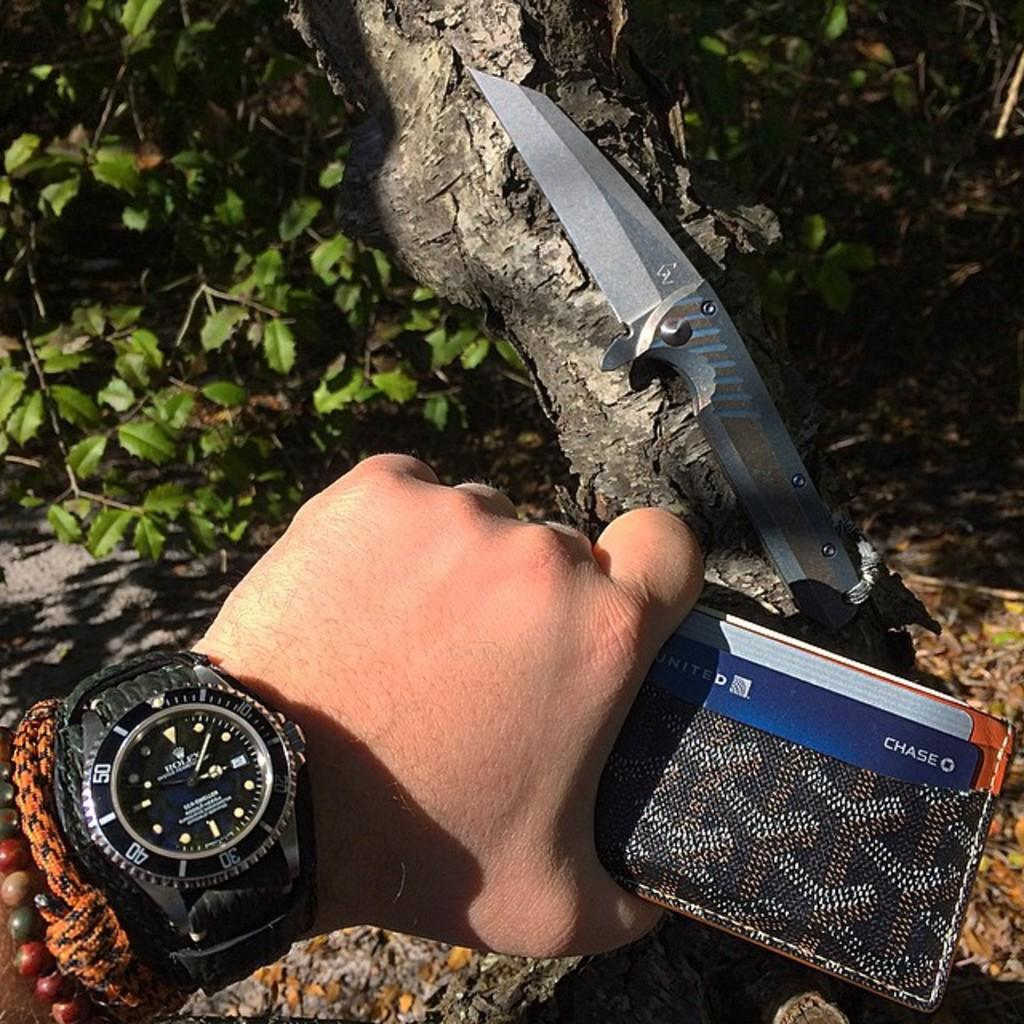Provide a one-sentence caption for the provided image. A man holding a wallet is wearing a Rolex watch. 